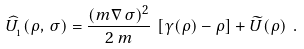<formula> <loc_0><loc_0><loc_500><loc_500>\widehat { U } _ { _ { 1 } } ( \rho , \, \sigma ) = \frac { ( { m \nabla } \, \sigma ) ^ { 2 } } { 2 \, m } \, \left [ \gamma ( \rho ) - \rho \right ] + \widetilde { U } ( \rho ) \ .</formula> 